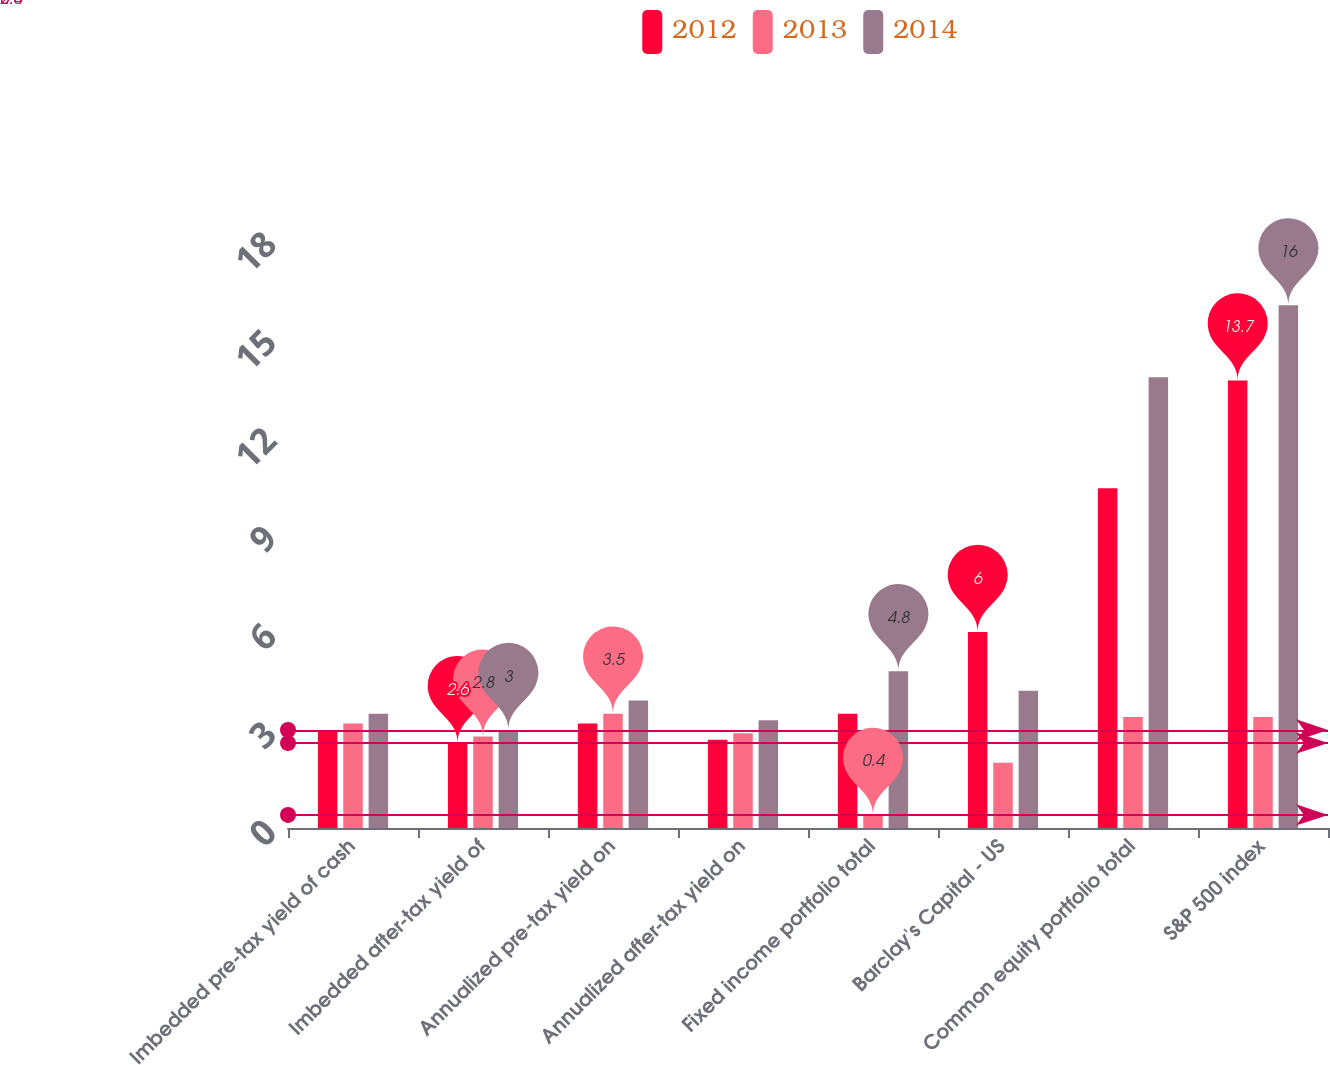Convert chart. <chart><loc_0><loc_0><loc_500><loc_500><stacked_bar_chart><ecel><fcel>Imbedded pre-tax yield of cash<fcel>Imbedded after-tax yield of<fcel>Annualized pre-tax yield on<fcel>Annualized after-tax yield on<fcel>Fixed income portfolio total<fcel>Barclay's Capital - US<fcel>Common equity portfolio total<fcel>S&P 500 index<nl><fcel>2012<fcel>3<fcel>2.6<fcel>3.2<fcel>2.7<fcel>3.5<fcel>6<fcel>10.4<fcel>13.7<nl><fcel>2013<fcel>3.2<fcel>2.8<fcel>3.5<fcel>2.9<fcel>0.4<fcel>2<fcel>3.4<fcel>3.4<nl><fcel>2014<fcel>3.5<fcel>3<fcel>3.9<fcel>3.3<fcel>4.8<fcel>4.2<fcel>13.8<fcel>16<nl></chart> 